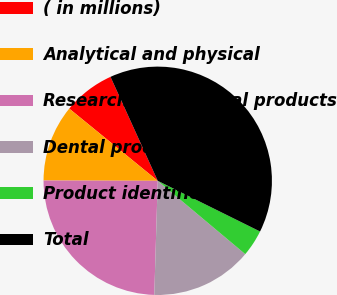Convert chart. <chart><loc_0><loc_0><loc_500><loc_500><pie_chart><fcel>( in millions)<fcel>Analytical and physical<fcel>Research and medical products<fcel>Dental products<fcel>Product identification<fcel>Total<nl><fcel>7.32%<fcel>10.85%<fcel>24.56%<fcel>14.38%<fcel>3.78%<fcel>39.11%<nl></chart> 